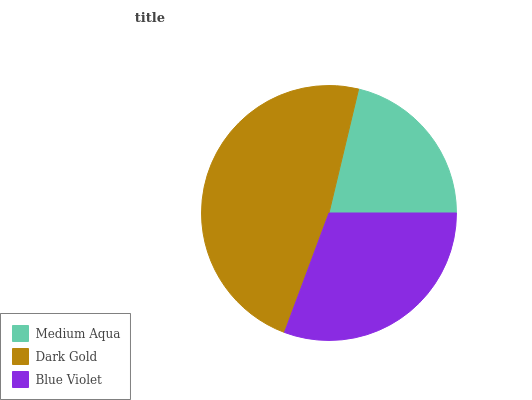Is Medium Aqua the minimum?
Answer yes or no. Yes. Is Dark Gold the maximum?
Answer yes or no. Yes. Is Blue Violet the minimum?
Answer yes or no. No. Is Blue Violet the maximum?
Answer yes or no. No. Is Dark Gold greater than Blue Violet?
Answer yes or no. Yes. Is Blue Violet less than Dark Gold?
Answer yes or no. Yes. Is Blue Violet greater than Dark Gold?
Answer yes or no. No. Is Dark Gold less than Blue Violet?
Answer yes or no. No. Is Blue Violet the high median?
Answer yes or no. Yes. Is Blue Violet the low median?
Answer yes or no. Yes. Is Medium Aqua the high median?
Answer yes or no. No. Is Dark Gold the low median?
Answer yes or no. No. 